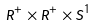Convert formula to latex. <formula><loc_0><loc_0><loc_500><loc_500>R ^ { + } \times R ^ { + } \times S ^ { 1 }</formula> 